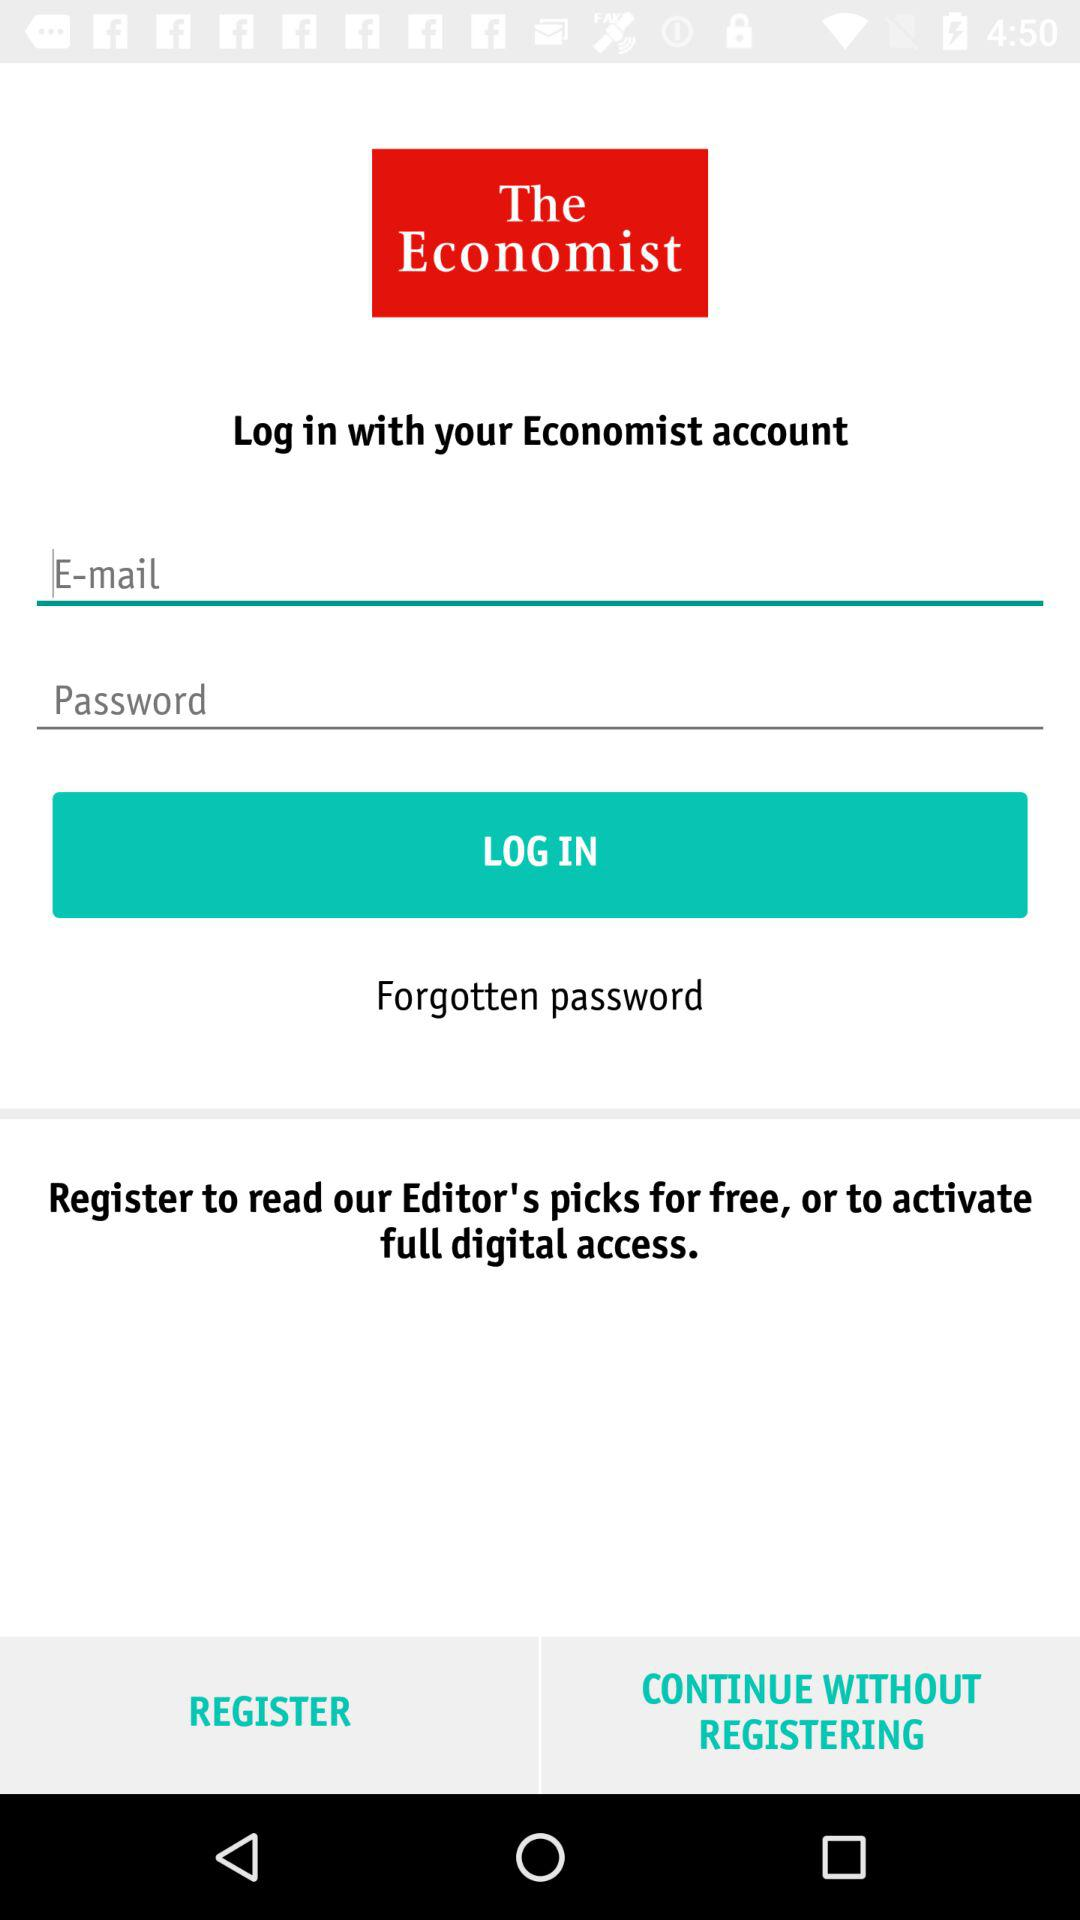What is the name of the application? The name of the application is "The Economist". 